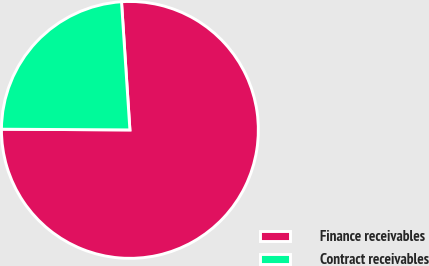<chart> <loc_0><loc_0><loc_500><loc_500><pie_chart><fcel>Finance receivables<fcel>Contract receivables<nl><fcel>76.13%<fcel>23.87%<nl></chart> 